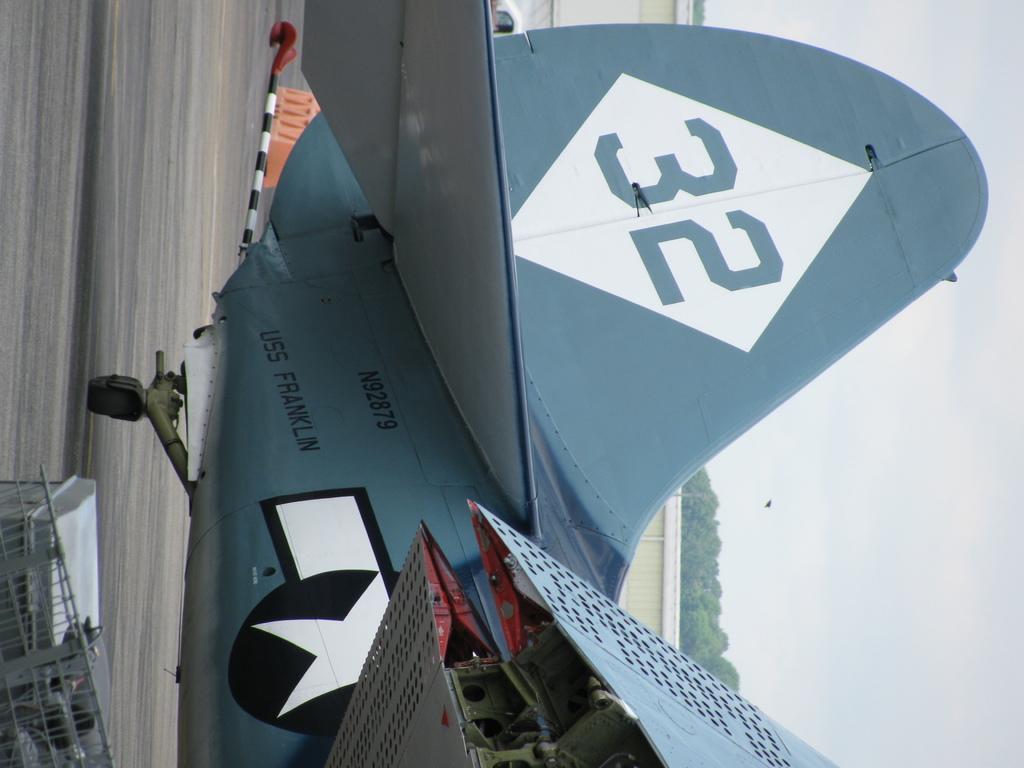What is the name of this airplane?
Your answer should be very brief. Uss franklin. What is the number?
Make the answer very short. 32. 